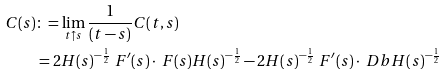<formula> <loc_0><loc_0><loc_500><loc_500>C ( s ) & \colon = \lim _ { t \uparrow s } { \frac { 1 } { ( t - s ) } C ( t , s ) } \\ & = 2 H ( s ) ^ { - \frac { 1 } { 2 } } \ F ^ { \prime } ( s ) \cdot \ F ( s ) H ( s ) ^ { - \frac { 1 } { 2 } } - 2 H ( s ) ^ { - \frac { 1 } { 2 } } \ F ^ { \prime } ( s ) \cdot \ D b H ( s ) ^ { - \frac { 1 } { 2 } }</formula> 